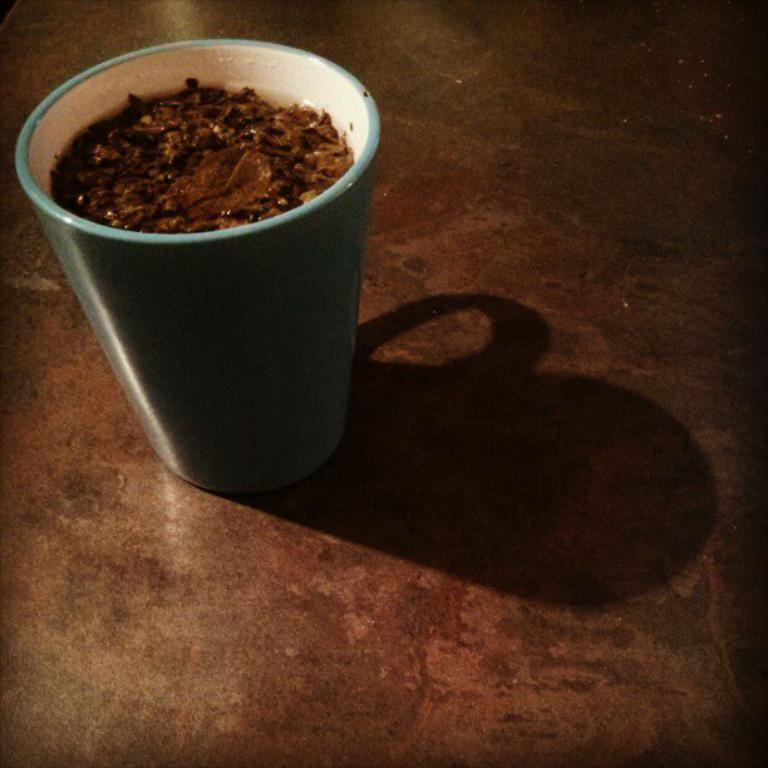What is present in the image? There is a cup in the image. What is inside the cup? The cup is filled with food. What type of drug is the daughter using in the image? There is no daughter or drug present in the image; it only features a cup filled with food. 